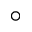Convert formula to latex. <formula><loc_0><loc_0><loc_500><loc_500>\circ</formula> 